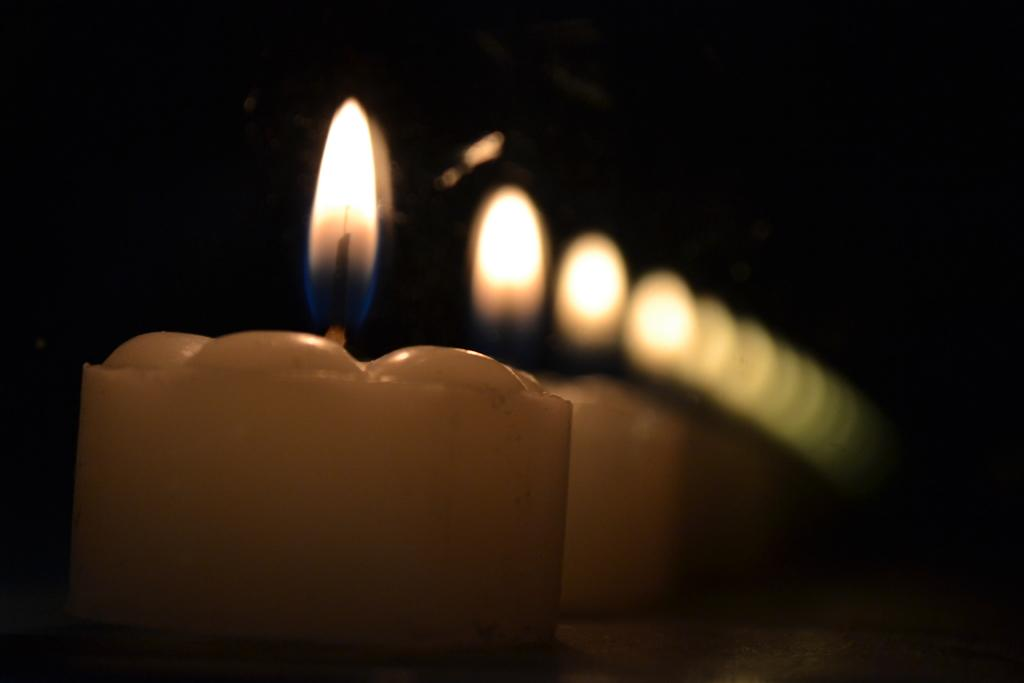What is the main object in the image? There is a candle with a flame in the image. Can you describe the background of the image? There are blurred candles in the background of the image. What type of quill is being used to write on the sponge in the image? There is no quill or sponge present in the image; it only features a candle with a flame and blurred candles in the background. 